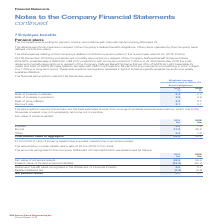According to Spirax Sarco Engineering Plc's financial document, Why are the post-retirement mortality assumptions regularly reviewed? in light of scheme-specific experience and more widely available statistics. The document states: "m trend. These assumptions are regularly reviewed in light of scheme-specific experience and more widely available statistics...." Also, What is the Company accounting for pension costs in accordance to? with International Accounting Standard 19. The document states: "any is accounting for pension costs in accordance with International Accounting Standard 19...." Also, What were the financial assumptions used at 31st December? The document contains multiple relevant values: Rate of increase in salaries, Rate of increase in pensions, Rate of price inflation, Discount rate. From the document: "ries 2.4 2.7 Rate of increase in pensions 2.8 2.9 Rate of price inflation 2.9 3.2 Discount rate 2.1 2.7 2018 % Rate of increase in salaries 2.4 2.7 Ra..." Additionally, In which year was the discount rate larger? According to the financial document, 2018. The relevant text states: "a long term trend of 1.25% p.a. At 31st December 2018 the post- retirement mortality assumptions in respect of the Company Defined Benefit Scheme follows..." Also, can you calculate: What was the absolute percentage change in the rate of price inflation from 2018 to 2019? Based on the calculation: 2.9%-3.2%, the result is -0.3 (percentage). This is based on the information: "e in pensions 2.8 2.9 Rate of price inflation 2.9 3.2 Discount rate 2.1 2.7 salaries 2.4 2.7 Rate of increase in pensions 2.8 2.9 Rate of price inflation 2.9 3.2 Discount rate 2.1 2.7..." The key data points involved are: 2.9, 3.2. Also, can you calculate: What was the absolute percentage change in the discount rate from 2018 to 2019? Based on the calculation: 2.1%-2.7%, the result is -0.6 (percentage). This is based on the information: "2018 % Rate of increase in salaries 2.4 2.7 Rate of increase in pensions 2.8 2.9 Rate of price inflation 2.9 3.2 Discount rate 2.1 2.7 2.9 Rate of price inflation 2.9 3.2 Discount rate 2.1 2.7..." The key data points involved are: 2.1, 2.7. 